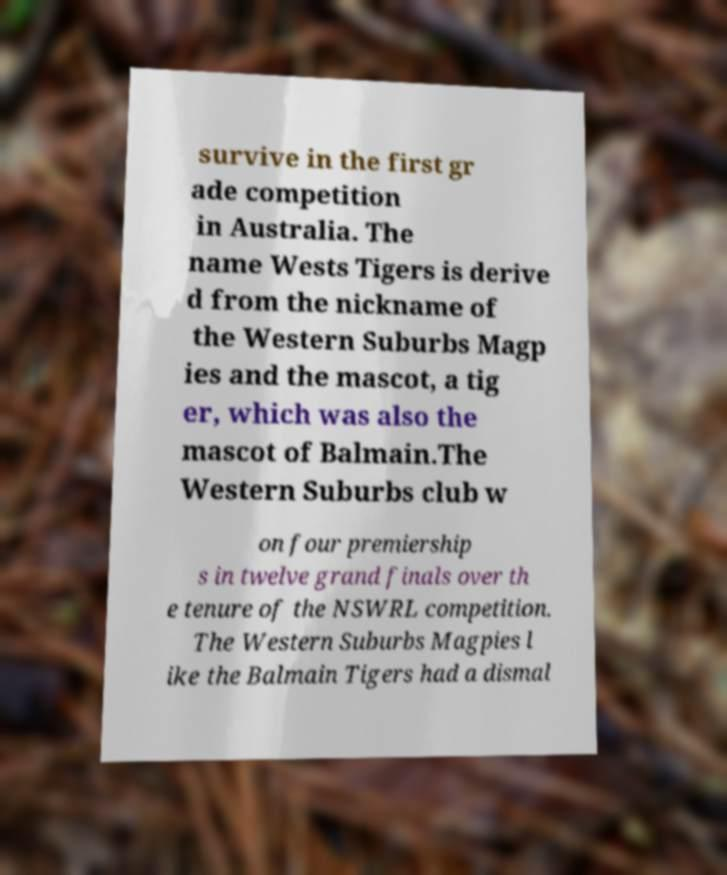Please identify and transcribe the text found in this image. survive in the first gr ade competition in Australia. The name Wests Tigers is derive d from the nickname of the Western Suburbs Magp ies and the mascot, a tig er, which was also the mascot of Balmain.The Western Suburbs club w on four premiership s in twelve grand finals over th e tenure of the NSWRL competition. The Western Suburbs Magpies l ike the Balmain Tigers had a dismal 